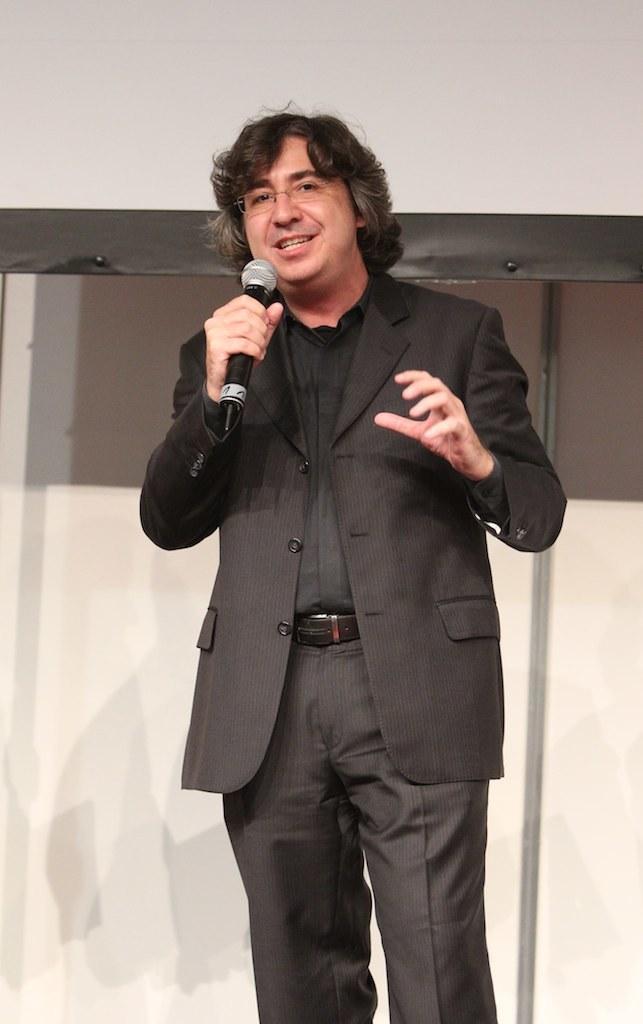In one or two sentences, can you explain what this image depicts? In this image in the center there is one man who is standing and he is holding a mike it seems that he is talking, on the background there is a wall. 